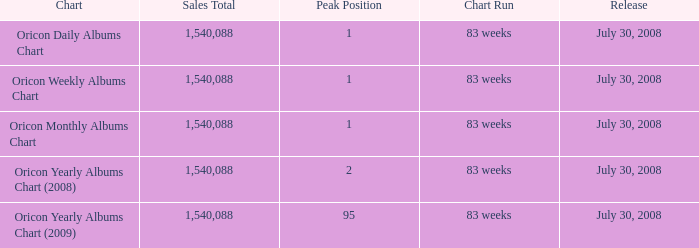Which Chart has a Peak Position of 1? Oricon Daily Albums Chart, Oricon Weekly Albums Chart, Oricon Monthly Albums Chart. 